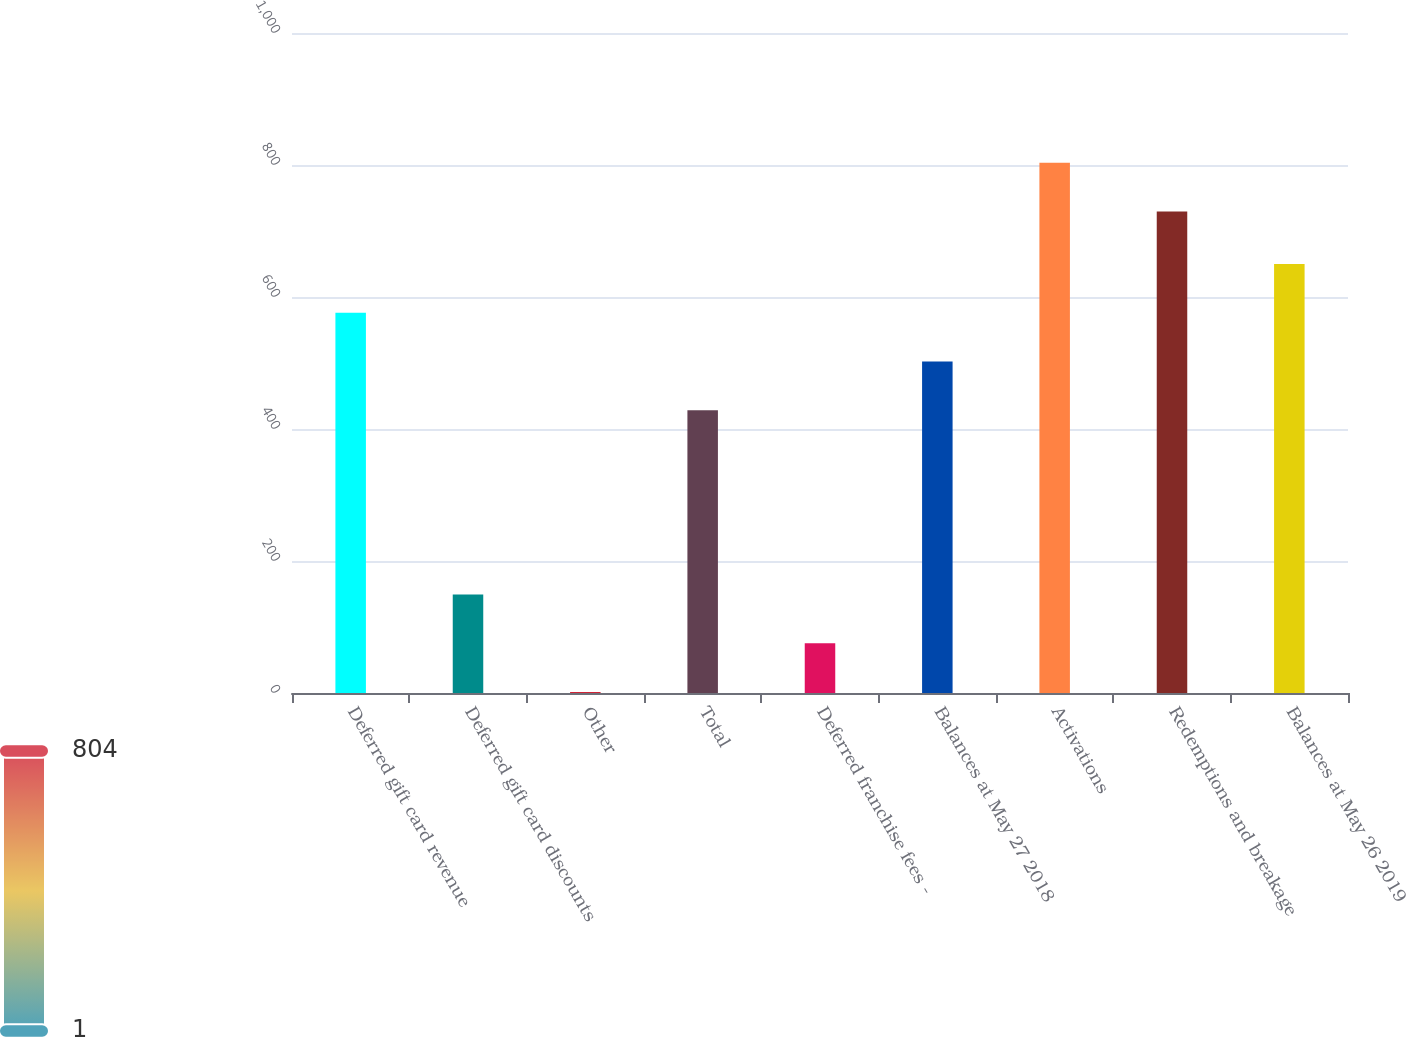Convert chart to OTSL. <chart><loc_0><loc_0><loc_500><loc_500><bar_chart><fcel>Deferred gift card revenue<fcel>Deferred gift card discounts<fcel>Other<fcel>Total<fcel>Deferred franchise fees -<fcel>Balances at May 27 2018<fcel>Activations<fcel>Redemptions and breakage<fcel>Balances at May 26 2019<nl><fcel>576.28<fcel>149.08<fcel>1.3<fcel>428.5<fcel>75.19<fcel>502.39<fcel>803.59<fcel>729.7<fcel>650.17<nl></chart> 